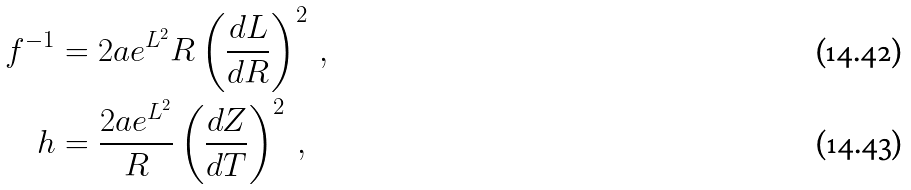<formula> <loc_0><loc_0><loc_500><loc_500>f ^ { - 1 } & = 2 a e ^ { L ^ { 2 } } R \left ( \frac { d L } { d R } \right ) ^ { 2 } \, , \\ h & = \frac { 2 a e ^ { L ^ { 2 } } } { R } \left ( \frac { d Z } { d T } \right ) ^ { 2 } \, ,</formula> 